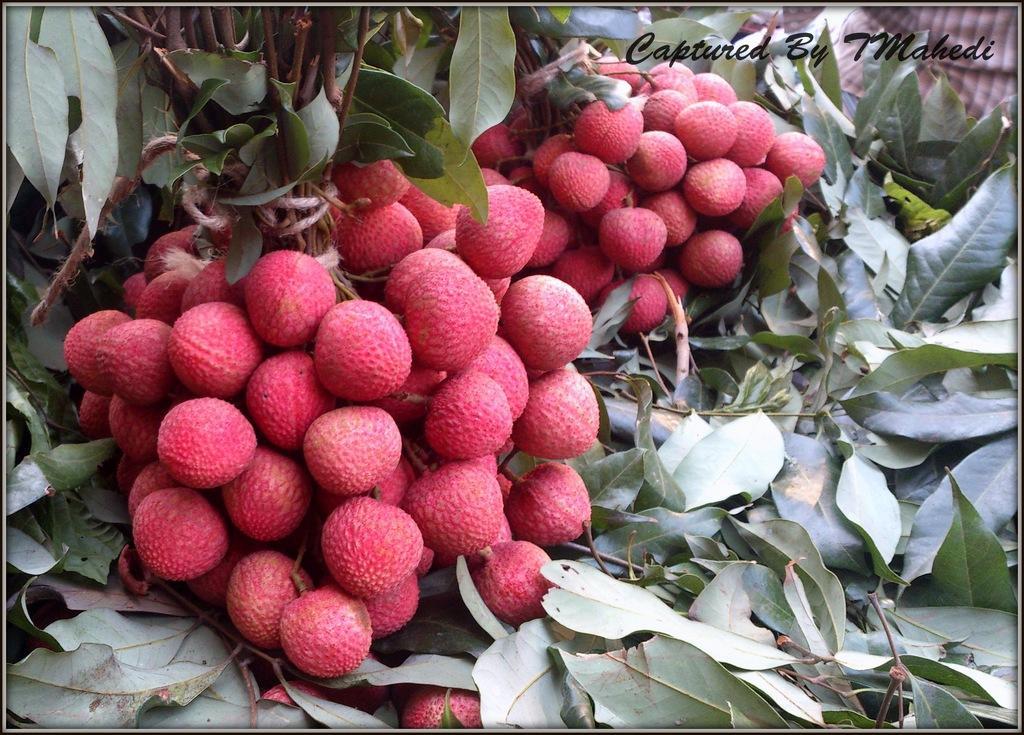In one or two sentences, can you explain what this image depicts? There are bunches of litchi. Also there are leaves. In the right top corner there is a watermark. 